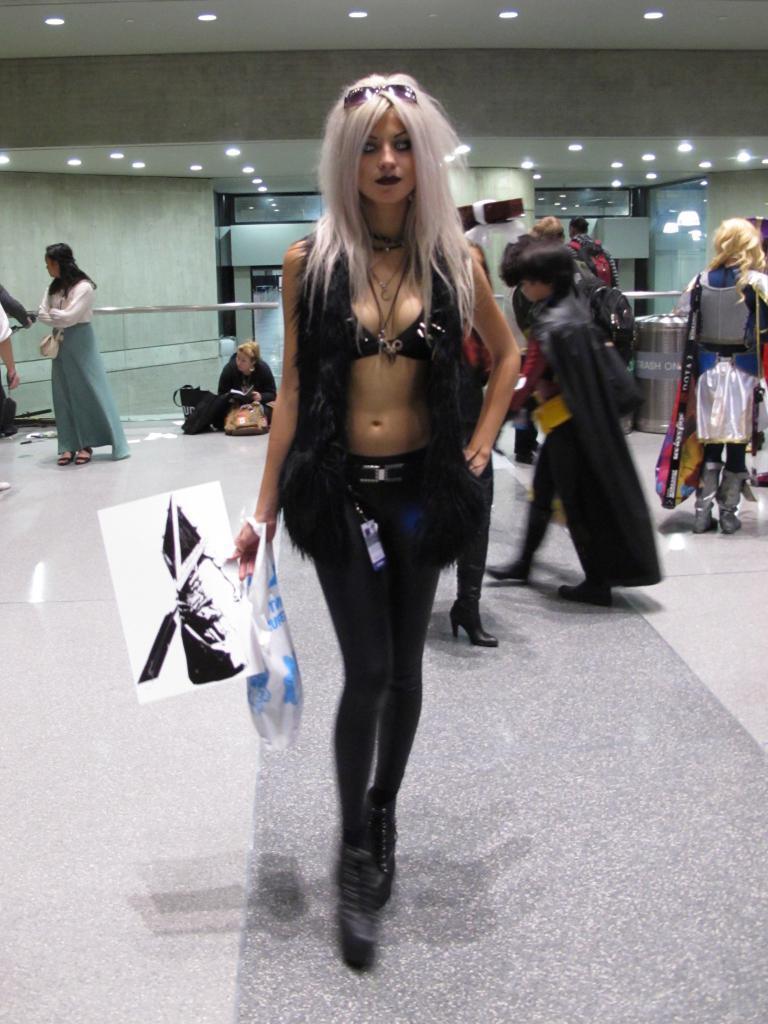How would you summarize this image in a sentence or two? In this image I can see a person standing wearing black color dress holding a paper and a cover. Background I can see few other people walking, a wall in white color and few lights. 